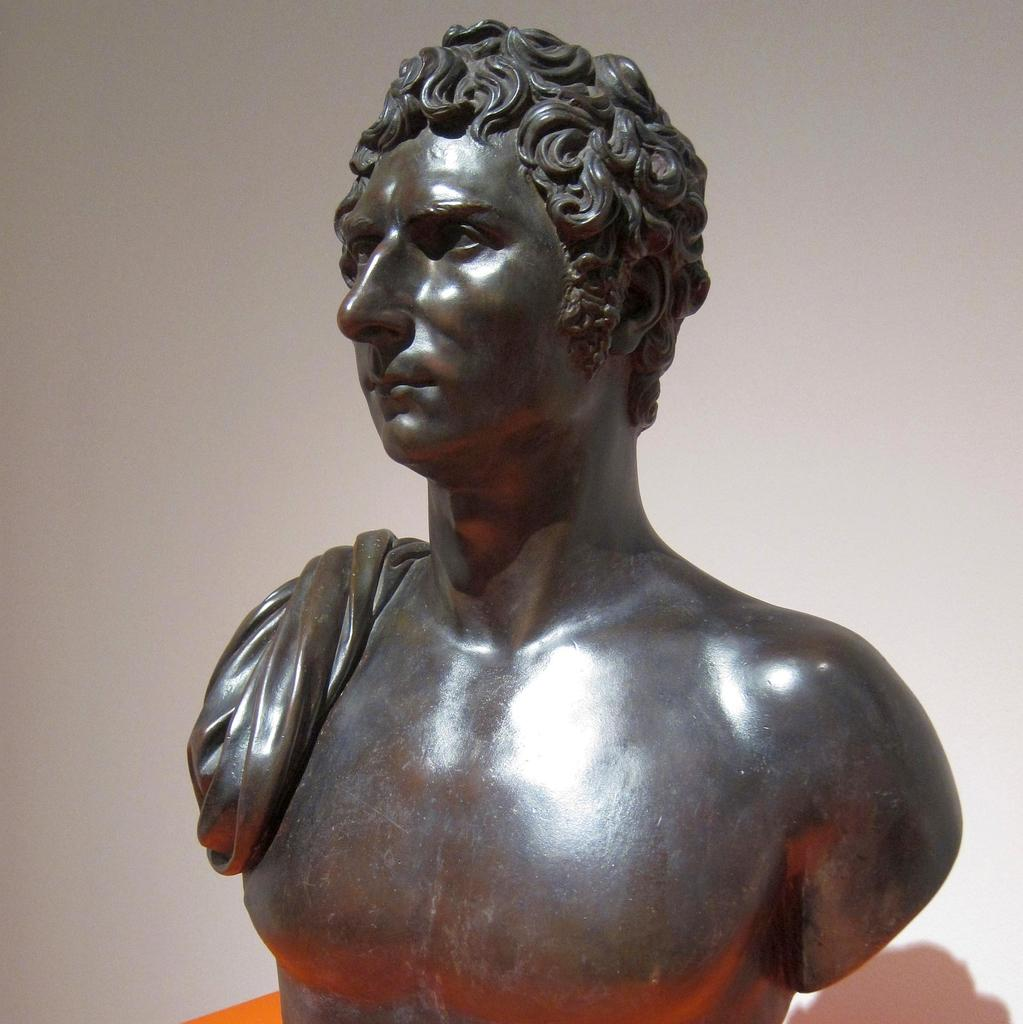What is the main subject of the image? There is a sculpture of a man in the image. What color is the sculpture? The sculpture is brown in color. What color is the background of the image? The background of the image is white. Can you describe any other features in the image? There is a shadow visible in the image. How many carriages are attached to the rake in the image? There is no rake or carriage present in the image. 